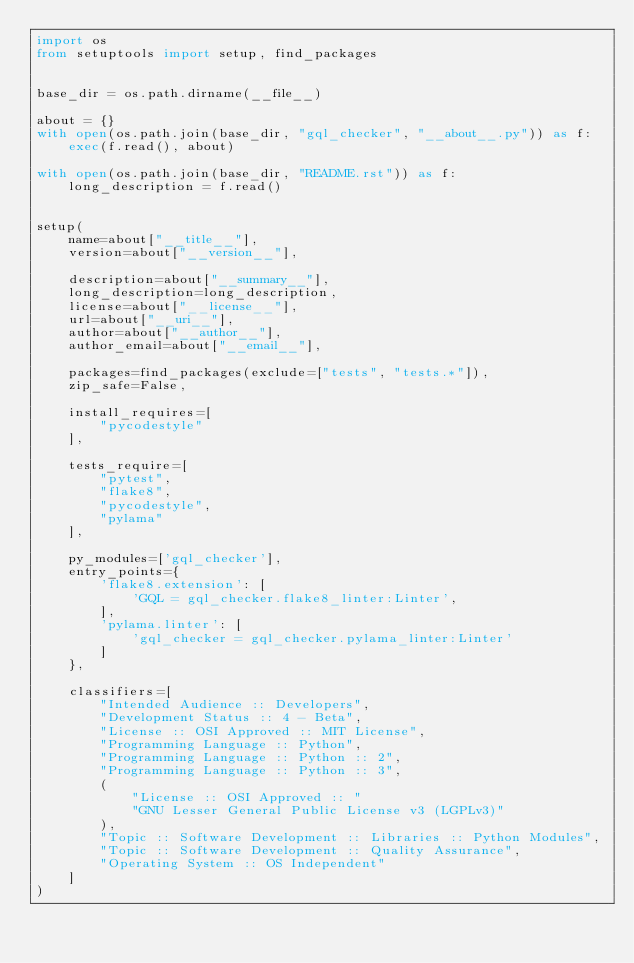Convert code to text. <code><loc_0><loc_0><loc_500><loc_500><_Python_>import os
from setuptools import setup, find_packages


base_dir = os.path.dirname(__file__)

about = {}
with open(os.path.join(base_dir, "gql_checker", "__about__.py")) as f:
    exec(f.read(), about)

with open(os.path.join(base_dir, "README.rst")) as f:
    long_description = f.read()


setup(
    name=about["__title__"],
    version=about["__version__"],

    description=about["__summary__"],
    long_description=long_description,
    license=about["__license__"],
    url=about["__uri__"],
    author=about["__author__"],
    author_email=about["__email__"],

    packages=find_packages(exclude=["tests", "tests.*"]),
    zip_safe=False,

    install_requires=[
        "pycodestyle"
    ],

    tests_require=[
        "pytest",
        "flake8",
        "pycodestyle",
        "pylama"
    ],

    py_modules=['gql_checker'],
    entry_points={
        'flake8.extension': [
            'GQL = gql_checker.flake8_linter:Linter',
        ],
        'pylama.linter': [
            'gql_checker = gql_checker.pylama_linter:Linter'
        ]
    },

    classifiers=[
        "Intended Audience :: Developers",
        "Development Status :: 4 - Beta",
        "License :: OSI Approved :: MIT License",
        "Programming Language :: Python",
        "Programming Language :: Python :: 2",
        "Programming Language :: Python :: 3",
        (
            "License :: OSI Approved :: "
            "GNU Lesser General Public License v3 (LGPLv3)"
        ),
        "Topic :: Software Development :: Libraries :: Python Modules",
        "Topic :: Software Development :: Quality Assurance",
        "Operating System :: OS Independent"
    ]
)
</code> 